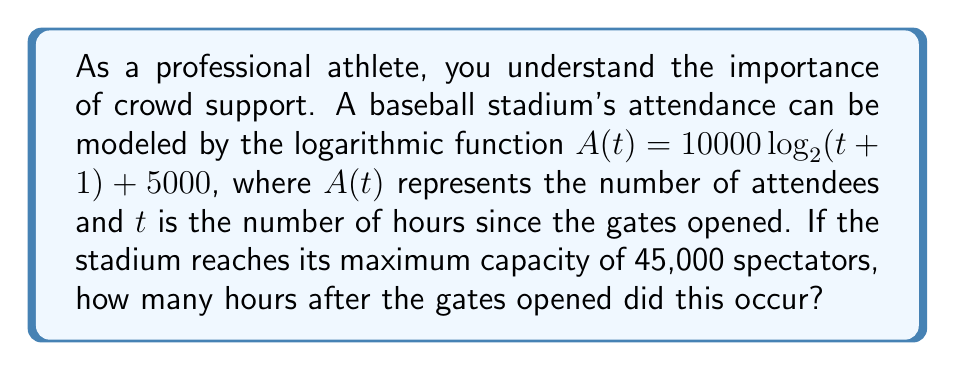Can you solve this math problem? Let's approach this step-by-step:

1) We need to find $t$ when $A(t) = 45000$. So, we set up the equation:
   
   $45000 = 10000 \log_2(t+1) + 5000$

2) Subtract 5000 from both sides:
   
   $40000 = 10000 \log_2(t+1)$

3) Divide both sides by 10000:
   
   $4 = \log_2(t+1)$

4) To solve for $t$, we need to apply the inverse function of $\log_2$, which is $2^x$:
   
   $2^4 = t+1$

5) Simplify:
   
   $16 = t+1$

6) Subtract 1 from both sides:
   
   $15 = t$

Therefore, the stadium reaches its maximum capacity 15 hours after the gates opened.
Answer: 15 hours 